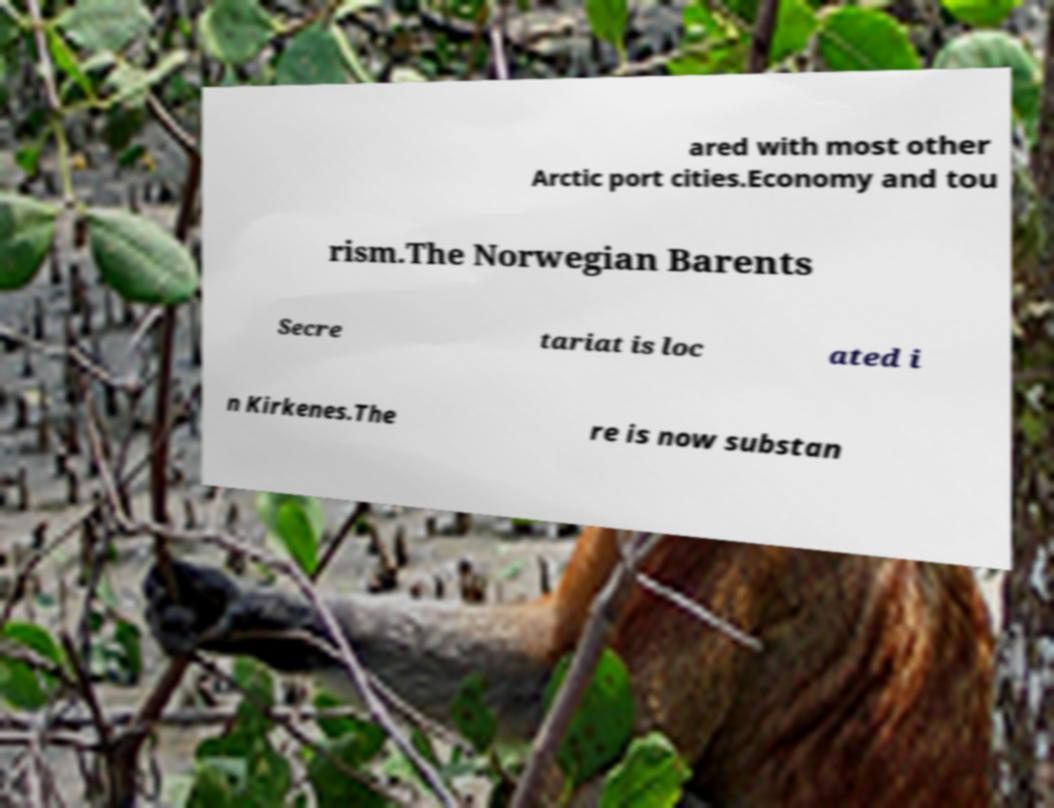What messages or text are displayed in this image? I need them in a readable, typed format. ared with most other Arctic port cities.Economy and tou rism.The Norwegian Barents Secre tariat is loc ated i n Kirkenes.The re is now substan 